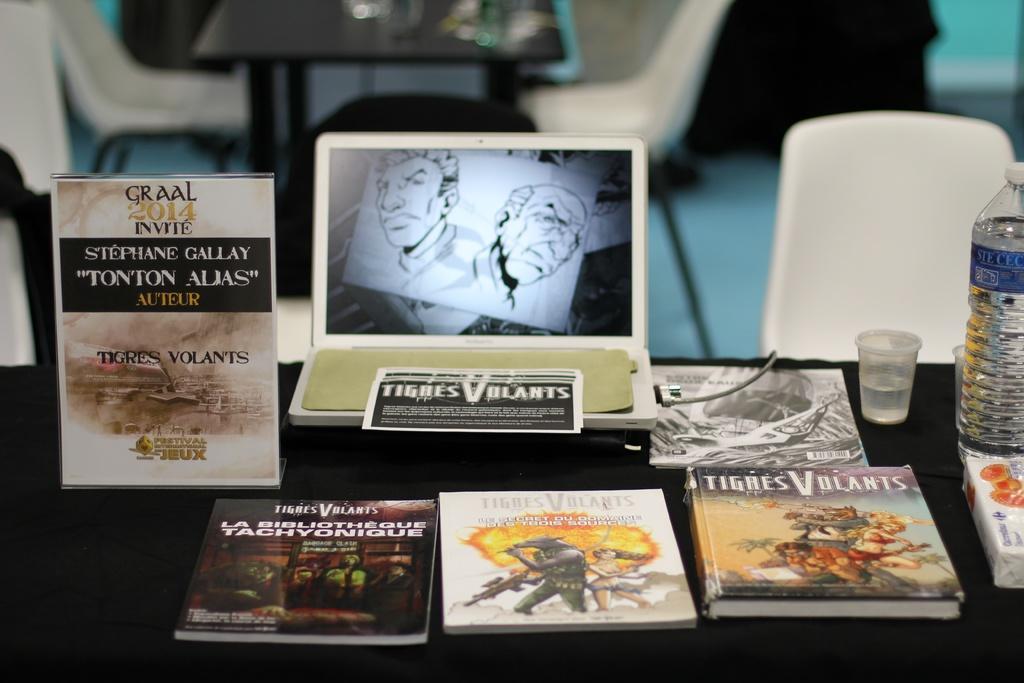Could you give a brief overview of what you see in this image? As we can see in the image there are tables and chairs. On tables there are books, laptop, glass and bottle. 